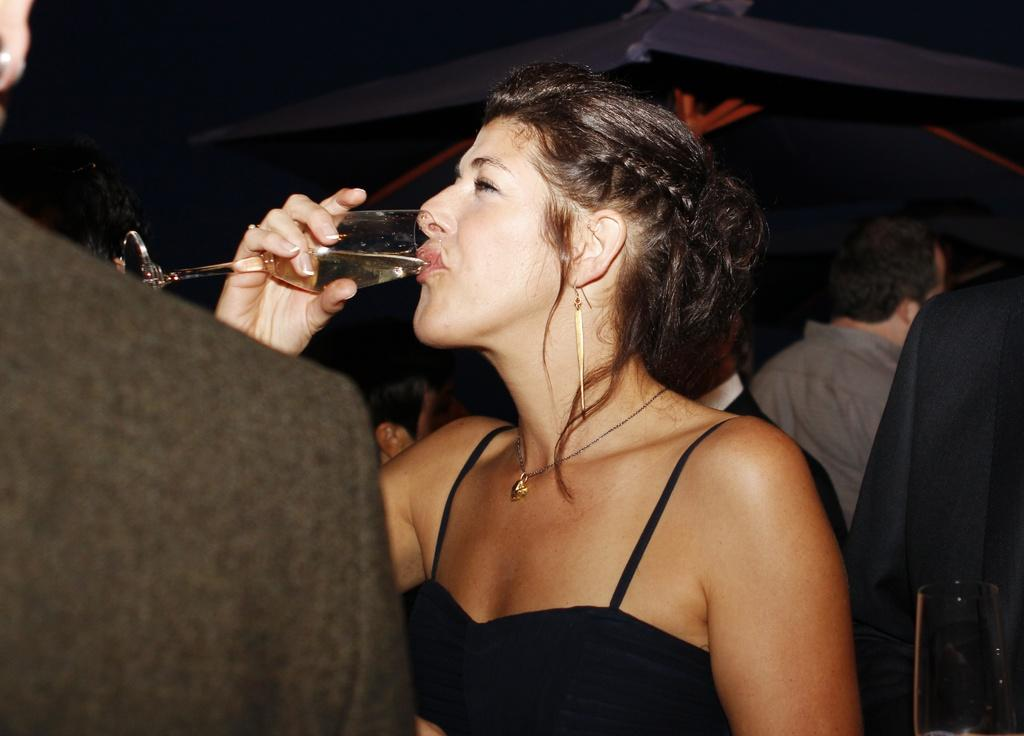How many people are in the image? There are people in the image, but the exact number is not specified. What is one person doing in the image? One person is holding a glass. What is the person holding the glass doing with it? The person holding the glass is drinking something. What type of shelter is visible in the image? There is a tent in the image. What type of education is being taught in the image? There is no indication of any educational activity in the image. How many rails are present in the image? There is no mention of rails in the image. 